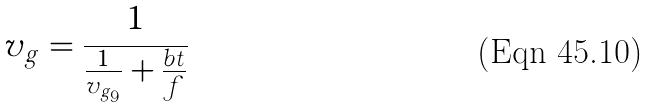<formula> <loc_0><loc_0><loc_500><loc_500>v _ { g } = \frac { 1 } { \frac { 1 } { v _ { g _ { 9 } } } + \frac { b t } { f } }</formula> 